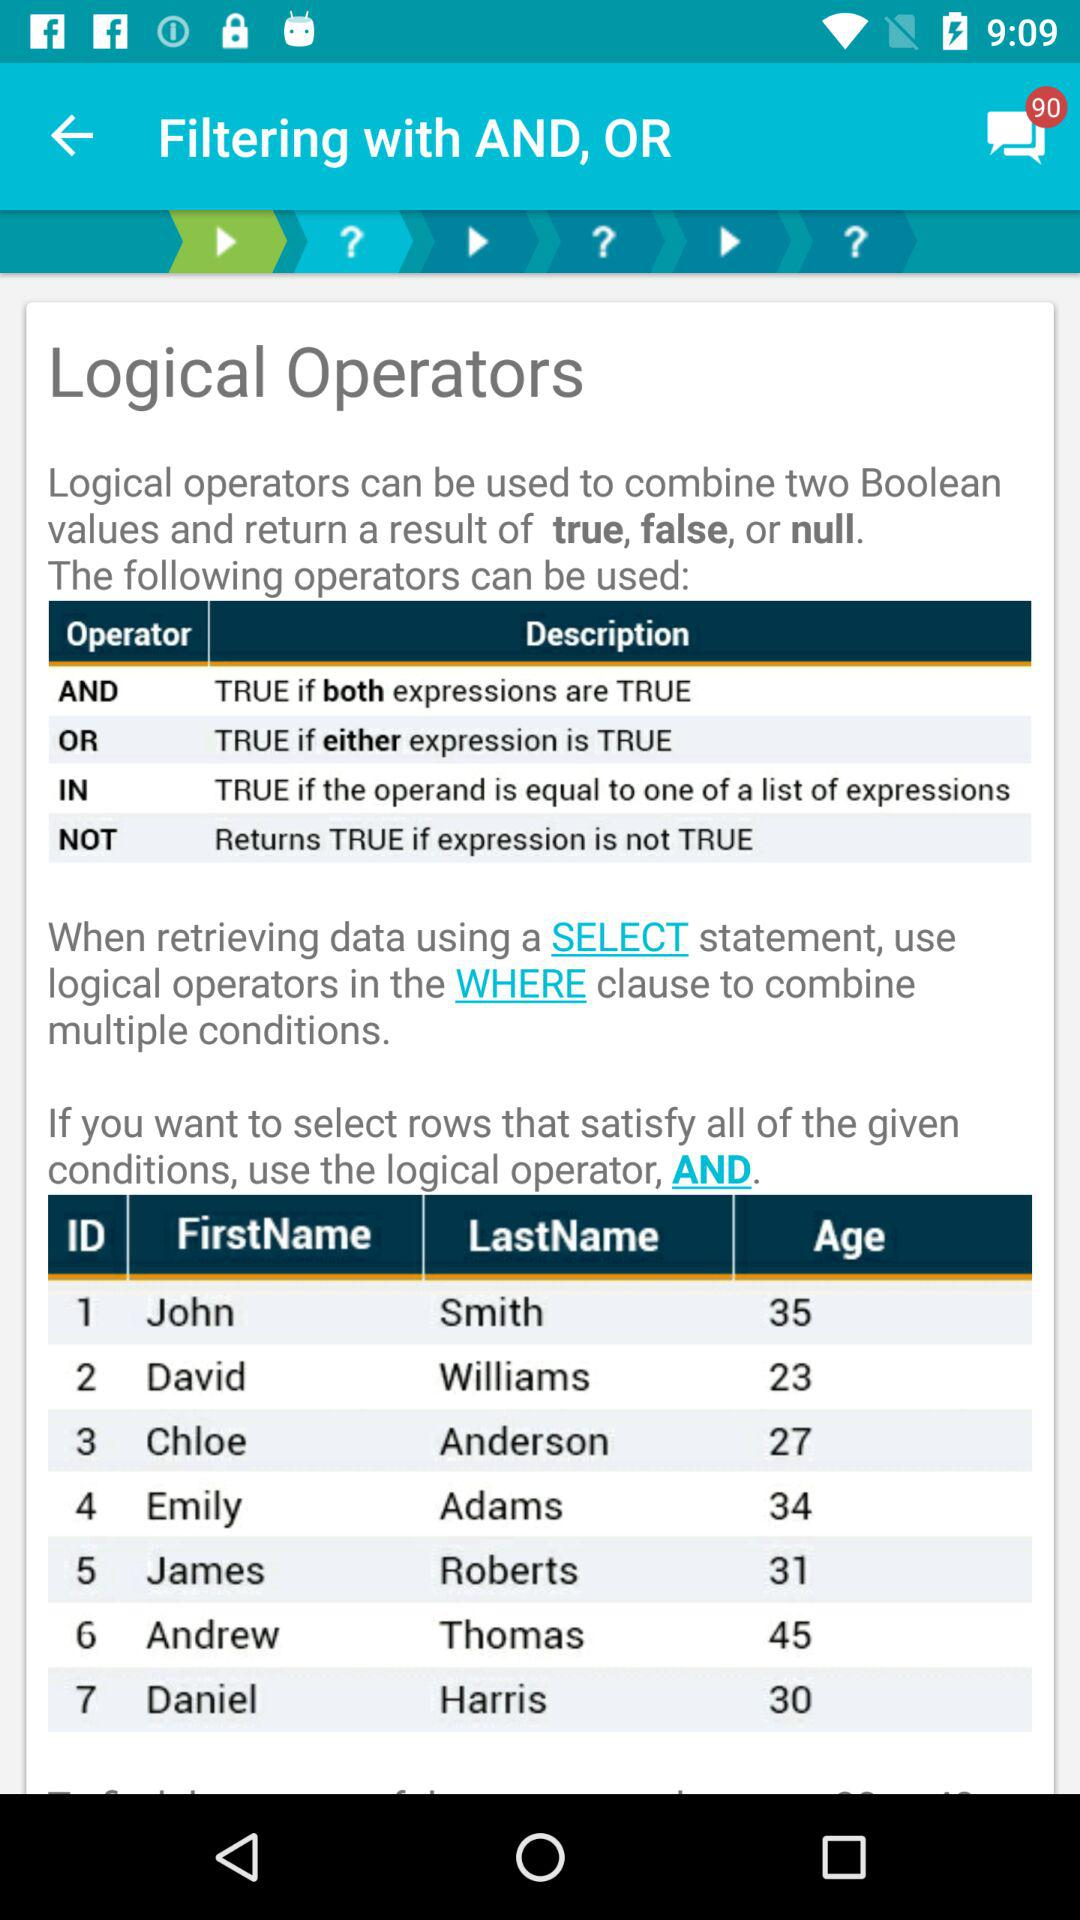How many messages are unread? There are 90 unread messages. 